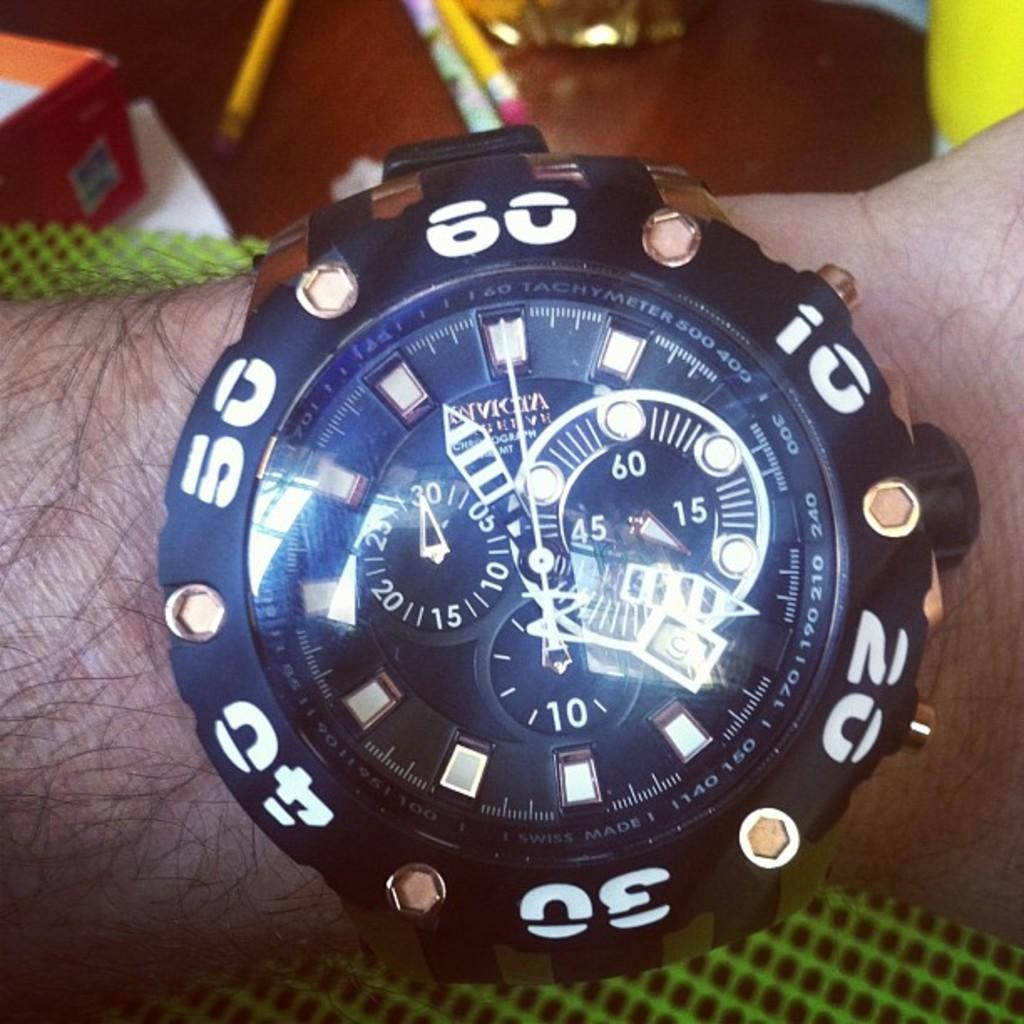What object is worn on a person's hand in the image? There is a wrist watch on a person's hand in the image. What stationery items can be seen in the image? There are pencils visible in the image. What type of table is present in the image? There is a wooden table in the image. Who is the creator of the wrist watch in the image? The image does not provide information about the creator of the wrist watch. 